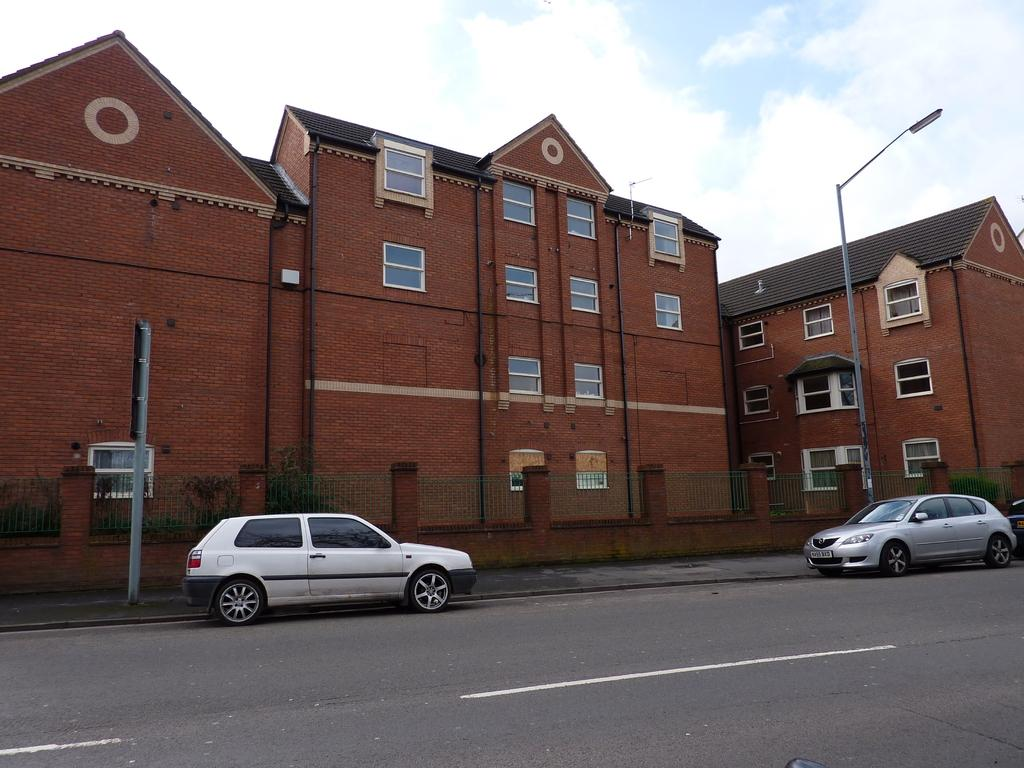What type of structures can be seen in the image? There are buildings in the image. What architectural elements are present in the image? There are iron grills in the image. What type of vegetation is visible in the image? There are plants in the image. What other objects can be seen in the image? There are poles in the image. What is the source of illumination in the image? There is light in the image. What type of signage is present in the image? There is a board in the image. What mode of transportation is visible in the image? There are vehicles on the road in the image. What can be seen in the background of the image? The sky is visible in the background of the image. What type of meat is being served at the zoo in the image? There is no zoo or meat present in the image. What story is being told on the board in the image? The board in the image does not appear to be telling a story; it may contain information or advertisements. 